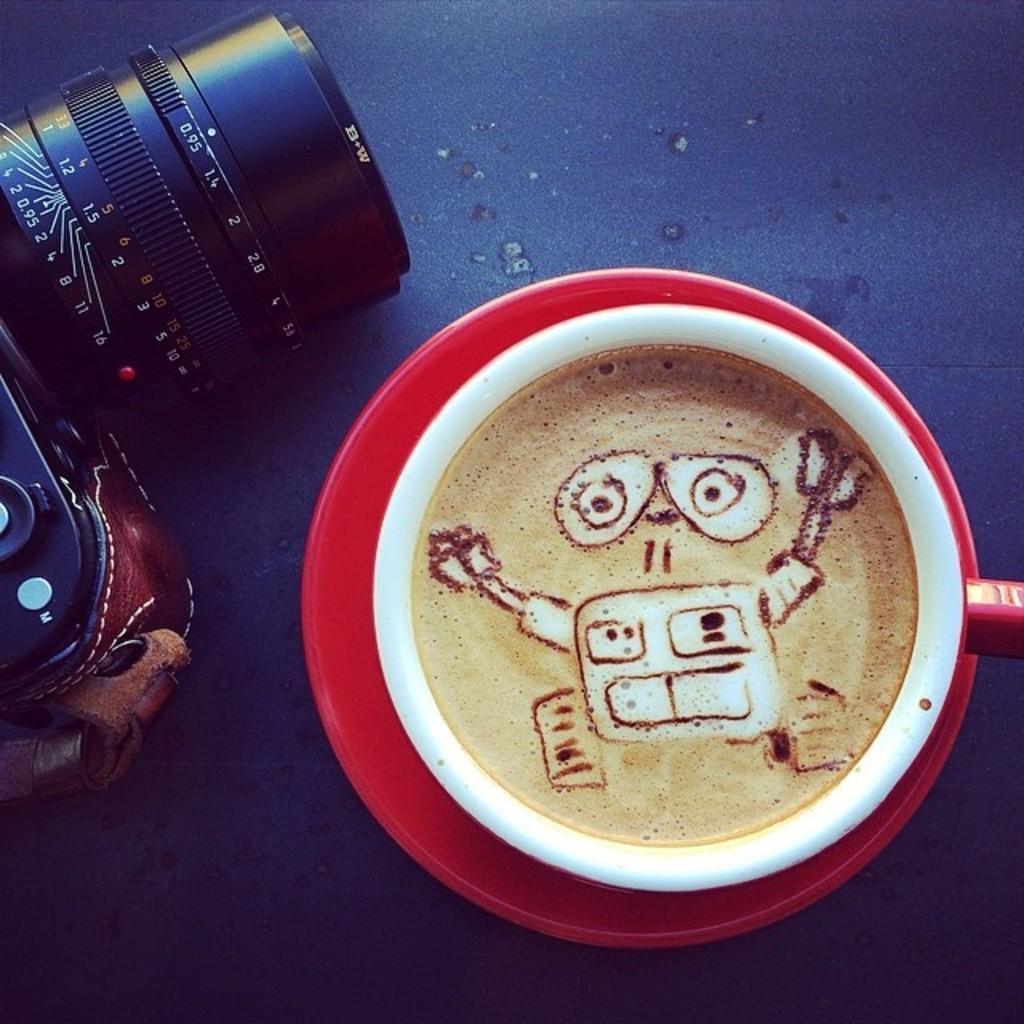Please provide a concise description of this image. In this picture I can see there is a camera and there is a coffee cup and a saucer. They are placed on a blue surface. 